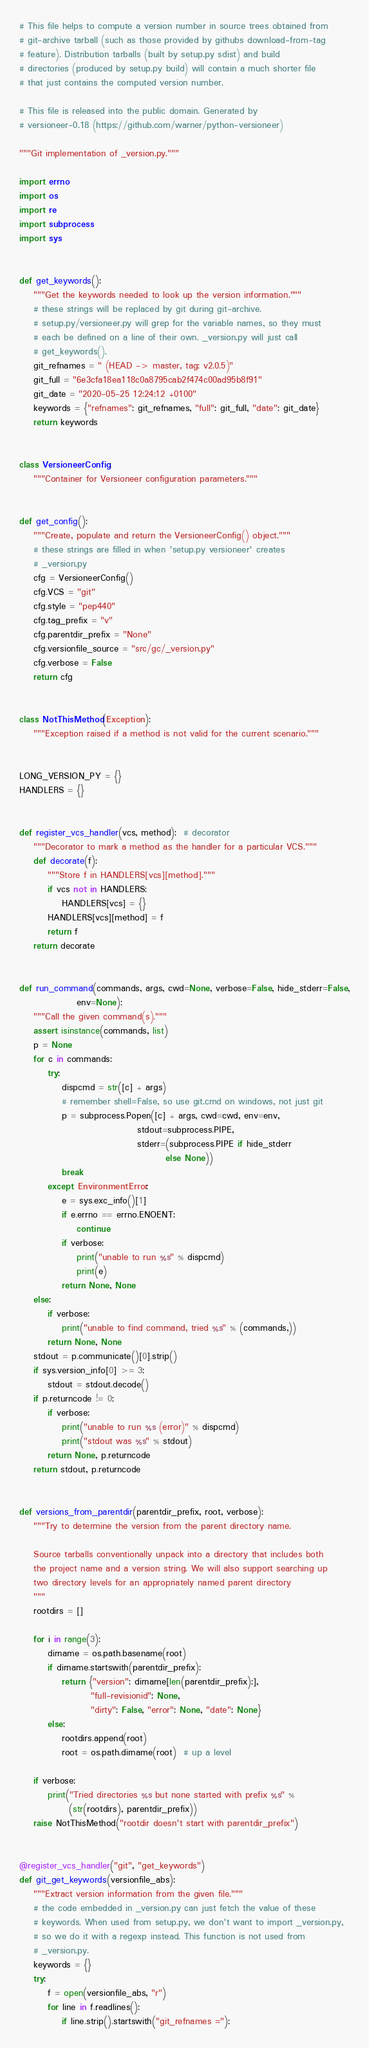Convert code to text. <code><loc_0><loc_0><loc_500><loc_500><_Python_>
# This file helps to compute a version number in source trees obtained from
# git-archive tarball (such as those provided by githubs download-from-tag
# feature). Distribution tarballs (built by setup.py sdist) and build
# directories (produced by setup.py build) will contain a much shorter file
# that just contains the computed version number.

# This file is released into the public domain. Generated by
# versioneer-0.18 (https://github.com/warner/python-versioneer)

"""Git implementation of _version.py."""

import errno
import os
import re
import subprocess
import sys


def get_keywords():
    """Get the keywords needed to look up the version information."""
    # these strings will be replaced by git during git-archive.
    # setup.py/versioneer.py will grep for the variable names, so they must
    # each be defined on a line of their own. _version.py will just call
    # get_keywords().
    git_refnames = " (HEAD -> master, tag: v2.0.5)"
    git_full = "6e3cfa18ea118c0a8795cab2f474c00ad95b8f91"
    git_date = "2020-05-25 12:24:12 +0100"
    keywords = {"refnames": git_refnames, "full": git_full, "date": git_date}
    return keywords


class VersioneerConfig:
    """Container for Versioneer configuration parameters."""


def get_config():
    """Create, populate and return the VersioneerConfig() object."""
    # these strings are filled in when 'setup.py versioneer' creates
    # _version.py
    cfg = VersioneerConfig()
    cfg.VCS = "git"
    cfg.style = "pep440"
    cfg.tag_prefix = "v"
    cfg.parentdir_prefix = "None"
    cfg.versionfile_source = "src/gc/_version.py"
    cfg.verbose = False
    return cfg


class NotThisMethod(Exception):
    """Exception raised if a method is not valid for the current scenario."""


LONG_VERSION_PY = {}
HANDLERS = {}


def register_vcs_handler(vcs, method):  # decorator
    """Decorator to mark a method as the handler for a particular VCS."""
    def decorate(f):
        """Store f in HANDLERS[vcs][method]."""
        if vcs not in HANDLERS:
            HANDLERS[vcs] = {}
        HANDLERS[vcs][method] = f
        return f
    return decorate


def run_command(commands, args, cwd=None, verbose=False, hide_stderr=False,
                env=None):
    """Call the given command(s)."""
    assert isinstance(commands, list)
    p = None
    for c in commands:
        try:
            dispcmd = str([c] + args)
            # remember shell=False, so use git.cmd on windows, not just git
            p = subprocess.Popen([c] + args, cwd=cwd, env=env,
                                 stdout=subprocess.PIPE,
                                 stderr=(subprocess.PIPE if hide_stderr
                                         else None))
            break
        except EnvironmentError:
            e = sys.exc_info()[1]
            if e.errno == errno.ENOENT:
                continue
            if verbose:
                print("unable to run %s" % dispcmd)
                print(e)
            return None, None
    else:
        if verbose:
            print("unable to find command, tried %s" % (commands,))
        return None, None
    stdout = p.communicate()[0].strip()
    if sys.version_info[0] >= 3:
        stdout = stdout.decode()
    if p.returncode != 0:
        if verbose:
            print("unable to run %s (error)" % dispcmd)
            print("stdout was %s" % stdout)
        return None, p.returncode
    return stdout, p.returncode


def versions_from_parentdir(parentdir_prefix, root, verbose):
    """Try to determine the version from the parent directory name.

    Source tarballs conventionally unpack into a directory that includes both
    the project name and a version string. We will also support searching up
    two directory levels for an appropriately named parent directory
    """
    rootdirs = []

    for i in range(3):
        dirname = os.path.basename(root)
        if dirname.startswith(parentdir_prefix):
            return {"version": dirname[len(parentdir_prefix):],
                    "full-revisionid": None,
                    "dirty": False, "error": None, "date": None}
        else:
            rootdirs.append(root)
            root = os.path.dirname(root)  # up a level

    if verbose:
        print("Tried directories %s but none started with prefix %s" %
              (str(rootdirs), parentdir_prefix))
    raise NotThisMethod("rootdir doesn't start with parentdir_prefix")


@register_vcs_handler("git", "get_keywords")
def git_get_keywords(versionfile_abs):
    """Extract version information from the given file."""
    # the code embedded in _version.py can just fetch the value of these
    # keywords. When used from setup.py, we don't want to import _version.py,
    # so we do it with a regexp instead. This function is not used from
    # _version.py.
    keywords = {}
    try:
        f = open(versionfile_abs, "r")
        for line in f.readlines():
            if line.strip().startswith("git_refnames ="):</code> 